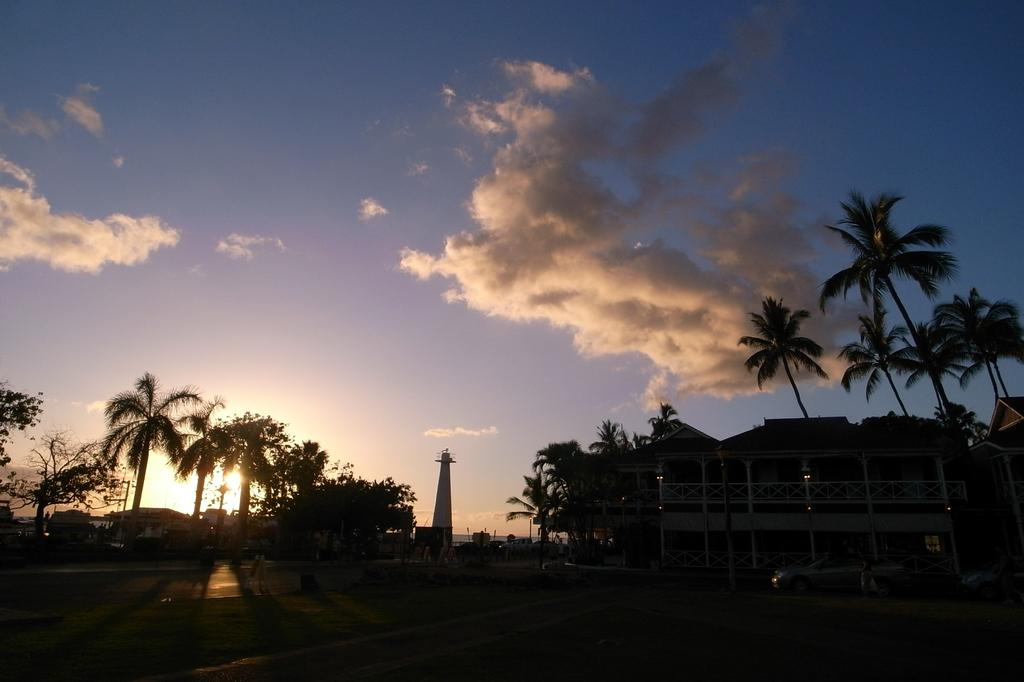What can be seen running through the image? There is a path in the image. What type of vegetation is present alongside the path? There are plants and trees on the sides of the path. Are there any man-made structures visible in the image? Yes, there are buildings on the sides of the path. What is visible in the sky in the image? The sky is visible in the image, and clouds are present. What type of alarm can be heard going off in the image? There is no alarm present in the image, and therefore no sound can be heard. 